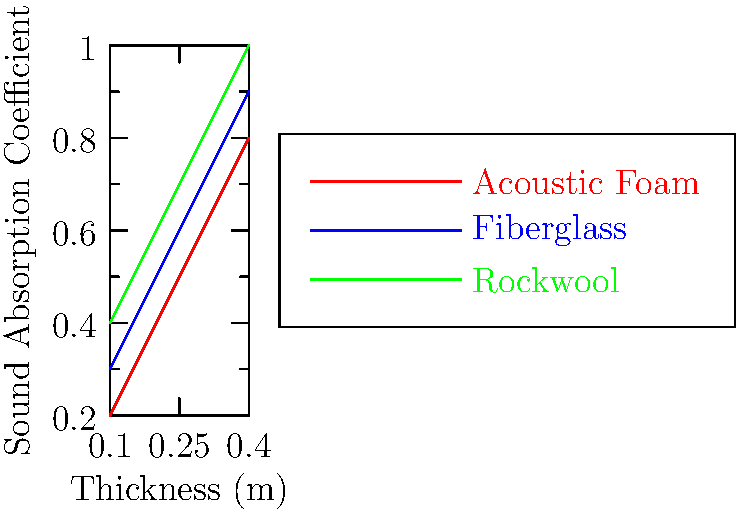As a sound engineer designing a recording studio in Sydney, you're tasked with creating a sound-absorbing wall. Based on the graph showing the relationship between material thickness and sound absorption coefficient for different materials, which material would be most effective for maximizing sound absorption while minimizing wall thickness? Consider the space constraints in urban Sydney studios. To answer this question, we need to analyze the graph and consider the following steps:

1. Understand the graph:
   - X-axis represents the thickness of the material in meters
   - Y-axis represents the sound absorption coefficient
   - Higher sound absorption coefficient indicates better sound absorption

2. Compare the materials:
   - Red line: Acoustic Foam
   - Blue line: Fiberglass
   - Green line: Rockwool

3. Analyze the performance:
   - For any given thickness, Rockwool (green line) has the highest sound absorption coefficient
   - Fiberglass (blue line) is the second-best performer
   - Acoustic Foam (red line) has the lowest sound absorption coefficient for any given thickness

4. Consider space constraints:
   - Urban Sydney studios likely have limited space
   - We want to maximize sound absorption while minimizing wall thickness

5. Make a decision:
   - Rockwool provides the highest sound absorption coefficient at the lowest thickness
   - This allows for effective sound absorption without requiring excessive wall thickness

Therefore, Rockwool would be the most effective material for maximizing sound absorption while minimizing wall thickness in a space-constrained Sydney recording studio.
Answer: Rockwool 